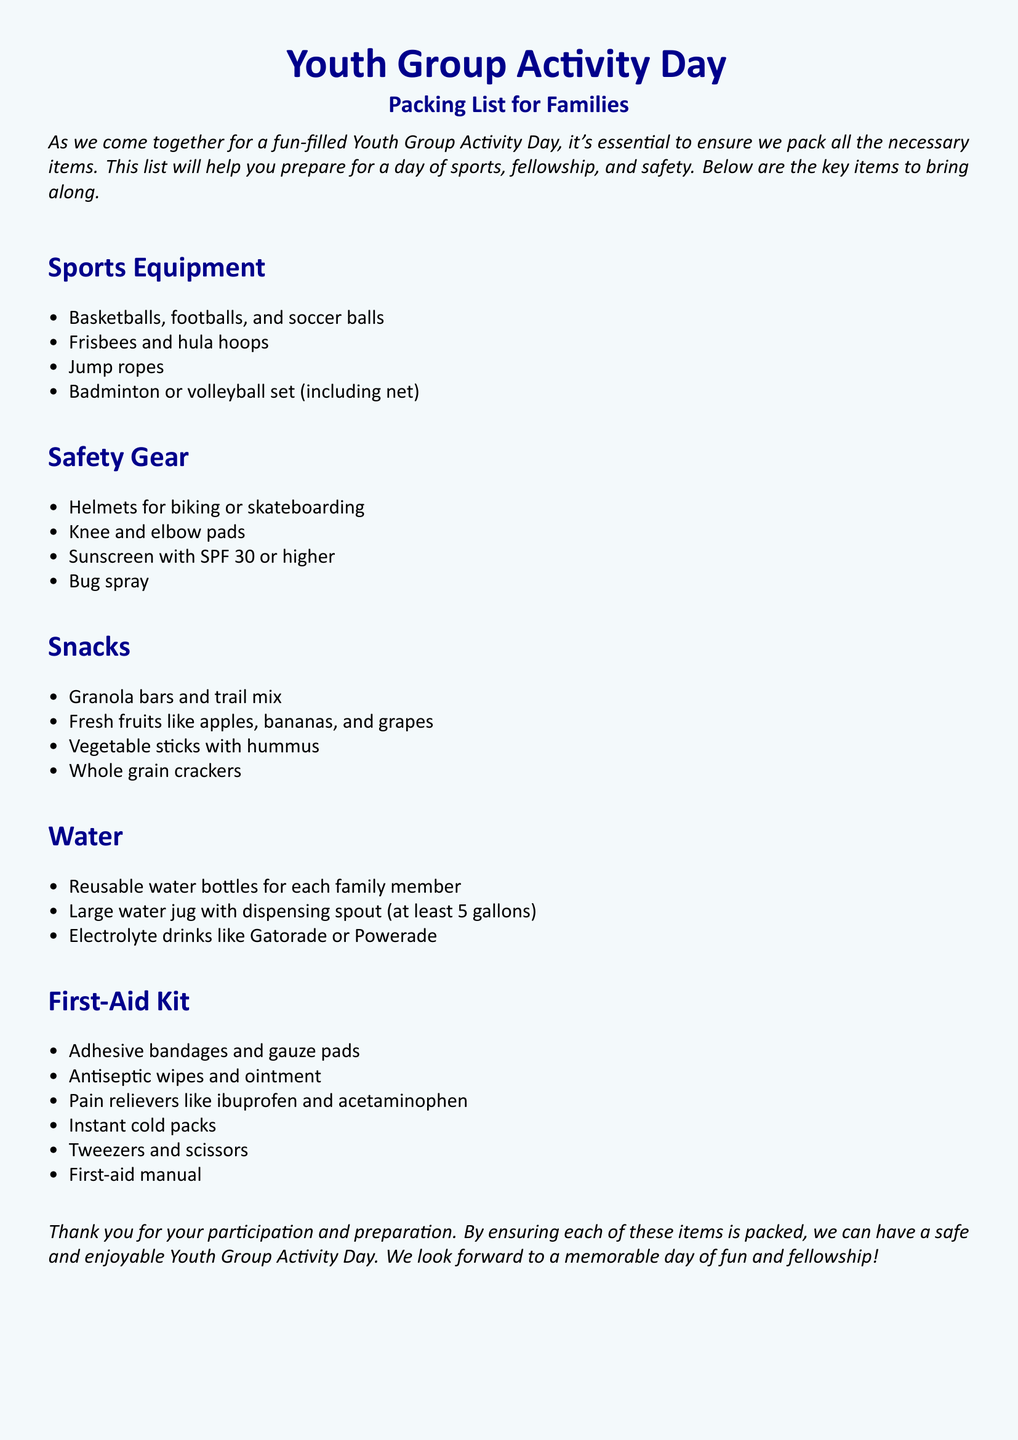What items are listed under sports equipment? The document provides a detailed list of sports equipment under its section, including items like basketballs, footballs, and soccer balls.
Answer: Basketballs, footballs, and soccer balls How many items should be packed in the first-aid kit? The first-aid kit section contains six specific items mentioned in the document.
Answer: Six What kind of fruits are suggested as snacks? The snacks section specifies fresh fruits that families should bring along for the event.
Answer: Apples, bananas, and grapes What should be included in the safety gear? The safety gear section enumerates essential items for safety, such as helmets for biking or skateboarding.
Answer: Helmets for biking or skateboarding How much water should the large water jug hold? The document explicitly states the required capacity for the large water jug to ensure adequate hydration during the event.
Answer: At least 5 gallons What is mentioned as a type of snack? The snacks section lists different types of snacks, including options that are healthy and easy to carry.
Answer: Granola bars and trail mix What is a recommended sport item for outdoor activities? The document suggests various sport items used during outdoor activities under the sports equipment section.
Answer: Frisbees and hula hoops What type of sunscreen is recommended? The safety gear section advises on the type of sunscreen families should bring along for protection against the sun.
Answer: SPF 30 or higher 